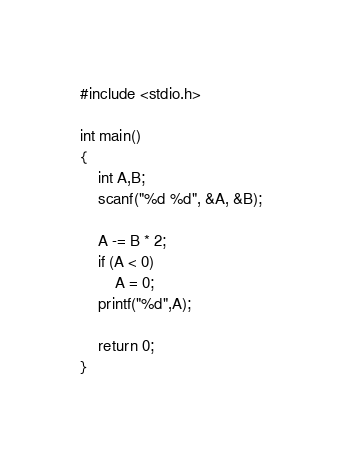<code> <loc_0><loc_0><loc_500><loc_500><_C_>#include <stdio.h>

int main()
{
	int A,B;
	scanf("%d %d", &A, &B);
	
	A -= B * 2;
	if (A < 0)
		A = 0;
	printf("%d",A);

	return 0;
}</code> 